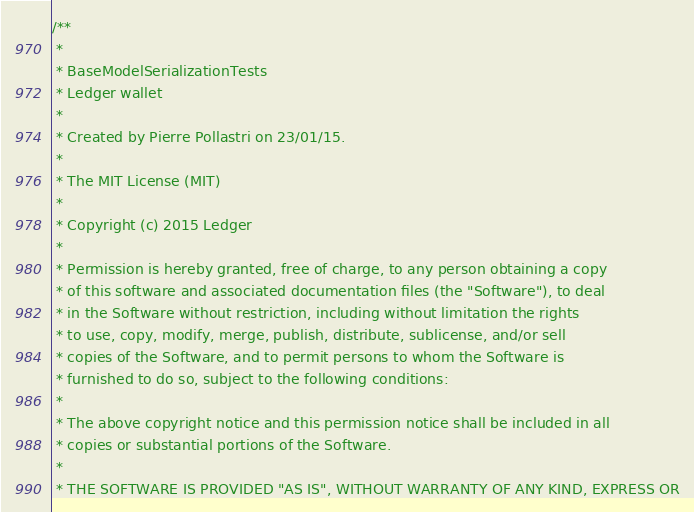<code> <loc_0><loc_0><loc_500><loc_500><_Scala_>/**
 *
 * BaseModelSerializationTests
 * Ledger wallet
 *
 * Created by Pierre Pollastri on 23/01/15.
 *
 * The MIT License (MIT)
 *
 * Copyright (c) 2015 Ledger
 *
 * Permission is hereby granted, free of charge, to any person obtaining a copy
 * of this software and associated documentation files (the "Software"), to deal
 * in the Software without restriction, including without limitation the rights
 * to use, copy, modify, merge, publish, distribute, sublicense, and/or sell
 * copies of the Software, and to permit persons to whom the Software is
 * furnished to do so, subject to the following conditions:
 *
 * The above copyright notice and this permission notice shall be included in all
 * copies or substantial portions of the Software.
 *
 * THE SOFTWARE IS PROVIDED "AS IS", WITHOUT WARRANTY OF ANY KIND, EXPRESS OR</code> 